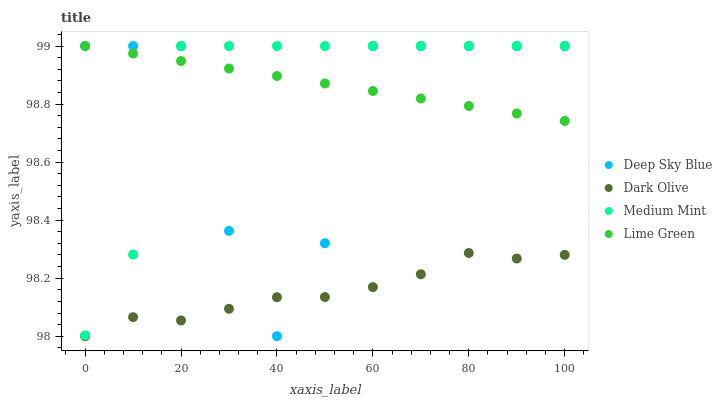Does Dark Olive have the minimum area under the curve?
Answer yes or no. Yes. Does Medium Mint have the maximum area under the curve?
Answer yes or no. Yes. Does Lime Green have the minimum area under the curve?
Answer yes or no. No. Does Lime Green have the maximum area under the curve?
Answer yes or no. No. Is Lime Green the smoothest?
Answer yes or no. Yes. Is Deep Sky Blue the roughest?
Answer yes or no. Yes. Is Dark Olive the smoothest?
Answer yes or no. No. Is Dark Olive the roughest?
Answer yes or no. No. Does Dark Olive have the lowest value?
Answer yes or no. Yes. Does Lime Green have the lowest value?
Answer yes or no. No. Does Deep Sky Blue have the highest value?
Answer yes or no. Yes. Does Dark Olive have the highest value?
Answer yes or no. No. Is Dark Olive less than Medium Mint?
Answer yes or no. Yes. Is Lime Green greater than Dark Olive?
Answer yes or no. Yes. Does Lime Green intersect Medium Mint?
Answer yes or no. Yes. Is Lime Green less than Medium Mint?
Answer yes or no. No. Is Lime Green greater than Medium Mint?
Answer yes or no. No. Does Dark Olive intersect Medium Mint?
Answer yes or no. No. 